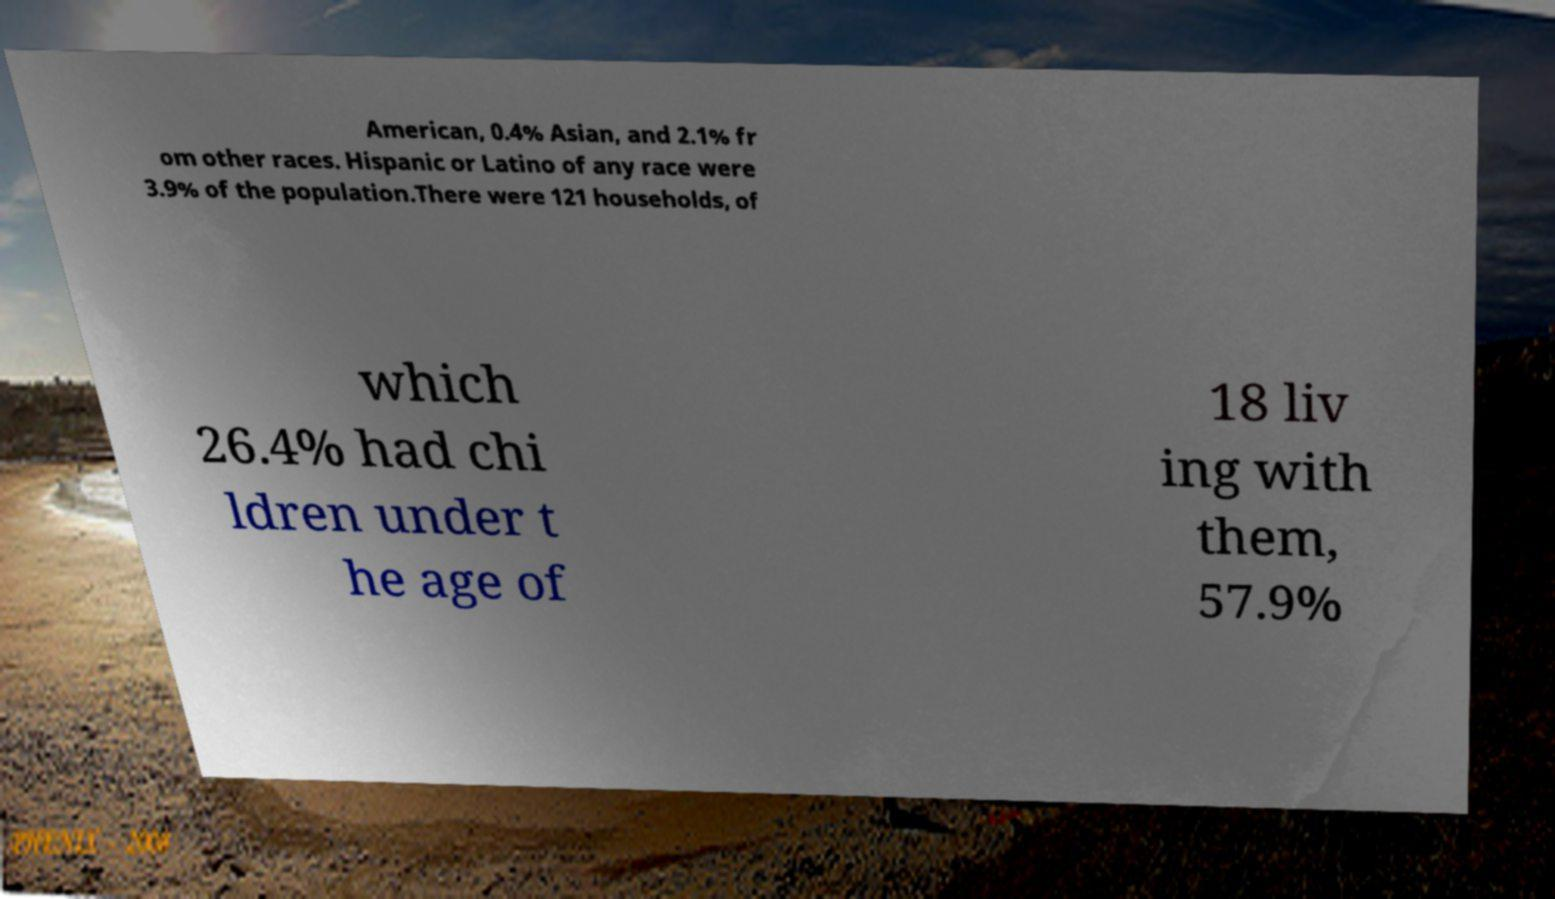Please read and relay the text visible in this image. What does it say? American, 0.4% Asian, and 2.1% fr om other races. Hispanic or Latino of any race were 3.9% of the population.There were 121 households, of which 26.4% had chi ldren under t he age of 18 liv ing with them, 57.9% 